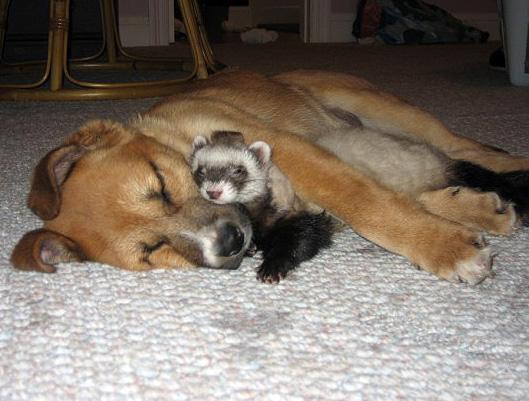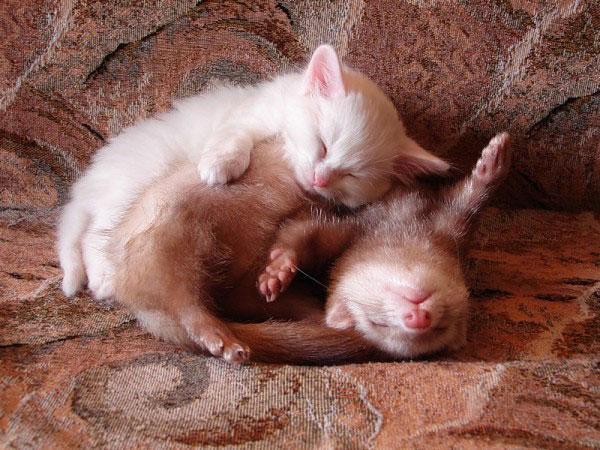The first image is the image on the left, the second image is the image on the right. Examine the images to the left and right. Is the description "There are ferrets cuddling with other species of animals." accurate? Answer yes or no. Yes. The first image is the image on the left, the second image is the image on the right. Evaluate the accuracy of this statement regarding the images: "In the left image, there are two ferrets.". Is it true? Answer yes or no. No. 